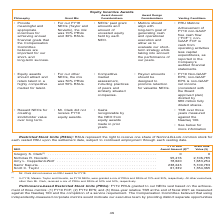According to Nortonlifelock's financial document, What does RSU stand for? Restricted Stock Units. The document states: "Restricted Stock Units (RSUs): RSUs represent the right to receive one share of NortonLifeLock common stock for each veste..." Also, What is the right to receive one share of NortonLifeLock common stock for each vested RSU upon the settlement date subjected to? continued employment through each vesting date. The document states: "h vested RSU upon the settlement date, subject to continued employment through each vesting date...." Also, What is Scott C. Taylor's FY19 RSU award amount? According to the financial document, 61,339. The relevant text states: "mir Kapuria . 238,243 5,100,783 Scott C. Taylor . 61,339 1,354,365..." Also, can you calculate: What is the total grant date value for all NEOs? Based on the calculation: 0+2,106,785+1,683,254+5,100,783+1,354,365, the result is 10245187. This is based on the information: "uria . 238,243 5,100,783 Scott C. Taylor . 61,339 1,354,365 S. Clark (1) . 0 0 Nicholas R. Noviello . 95,416 2,106,785 Amy L. Cappellanti-Wolf . 78,620 1,683,254 Samir Kapuria . 238,243 5,100,783 Scot..." The key data points involved are: 1,354,365, 1,683,254, 2,106,785. Additionally, Which NEO has the highest amount of FY19 RSU Award Amount? According to the financial document, Samir Kapuria. The relevant text states: "06,785 Amy L. Cappellanti-Wolf . 78,620 1,683,254 Samir Kapuria . 238,243 5,100,783 Scott C. Taylor . 61,339 1,354,365..." Also, can you calculate: How much more in grant date value does Nicholas R. Noviello have compared to Amy L. Cappellanti-Wolf? Based on the calculation: 2,106,785-1,683,254, the result is 423531. This is based on the information: "95,416 2,106,785 Amy L. Cappellanti-Wolf . 78,620 1,683,254 Samir Kapuria . 238,243 5,100,783 Scott C. Taylor . 61,339 1,354,365 S. Clark (1) . 0 0 Nicholas R. Noviello . 95,416 2,106,785 Amy L. Cappe..." The key data points involved are: 1,683,254, 2,106,785. 